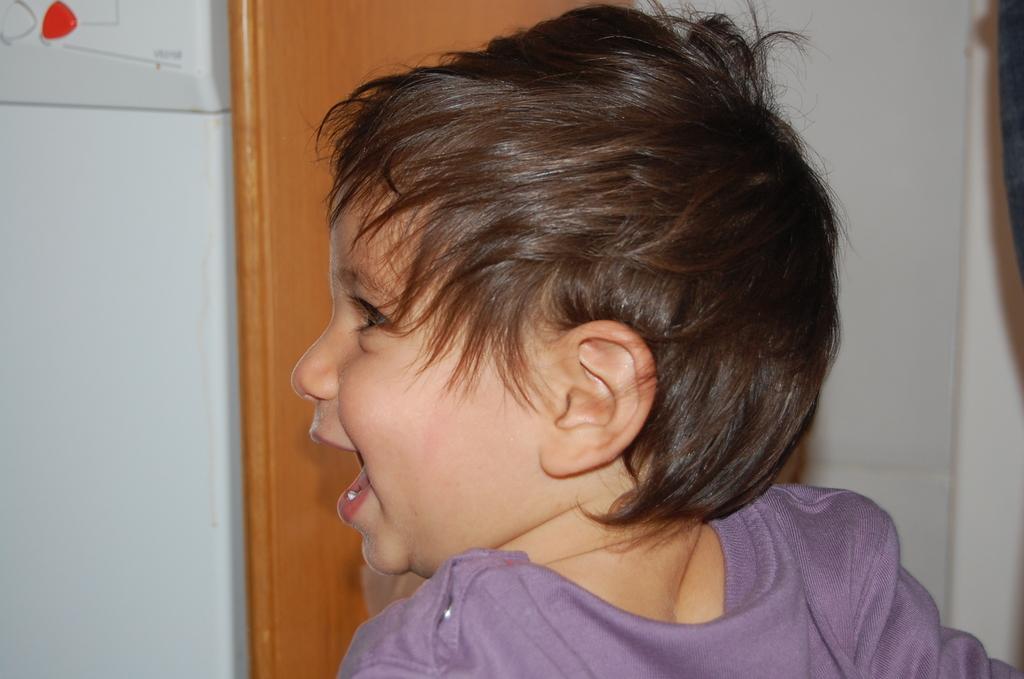Describe this image in one or two sentences. This is the picture of a kid with black hair, and a blue t-shirt in the foreground. There is a wooden block and the wall in the background. 